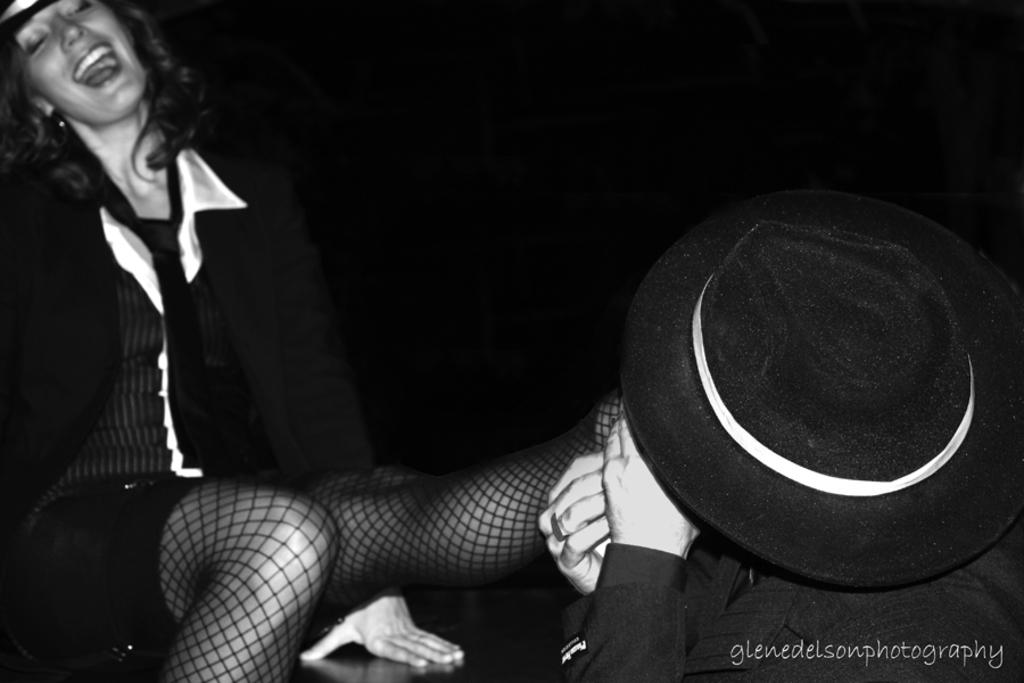How many people are in the image? There are two people in the image. What is the position of one of the people in the image? One person is sitting. What can be observed about the clothing of one of the people in the image? The other person is wearing a hat. Is there any additional information about the image itself? Yes, there is a watermark on the image. What statement does the parent make in the image? There is no parent present in the image, and therefore no statement can be attributed to a parent. 